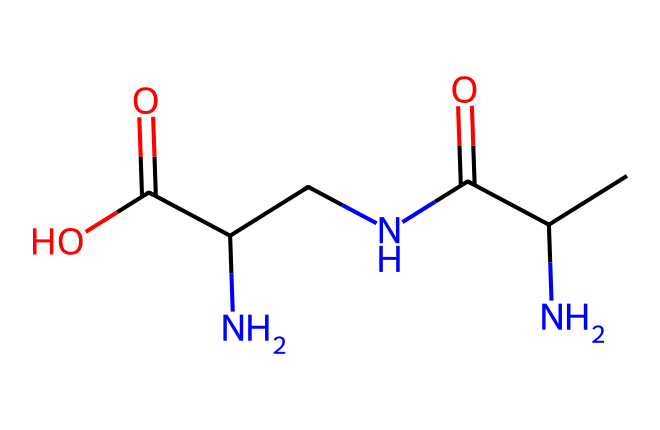How many nitrogen atoms are present in this chemical? By examining the SMILES representation, we can identify nitrogen atoms represented by the letter 'N'. There are three instances of 'N' indicating three nitrogen atoms in total.
Answer: three What type of bonding is indicated in this molecule? The molecule contains both carbon-carbon (C-C) and carbon-nitrogen (C-N) bonds. The structure connects various carbon and nitrogen atoms through single and double bonds as seen in the arrangement.
Answer: covalent What are the functional groups present in theanine? The molecule exhibits several functional groups including amines (due to the nitrogen atoms), carboxylic acids (the presence of C(=O)O), and an amide (C(=O)N) linkage as part of the structure.
Answer: amine, carboxylic acid, amide Is this compound classified as an amino acid? Looking at the presence of the amino group (-NH2) and carboxylic acid group (-COOH) features in its structure, it aligns with the classification criteria for amino acids.
Answer: yes What is the molecular formula based on this structure? By interpreting the composition from the SMILES, we can compute the molecular formula by counting each atom type (C, H, N, O). This leads us to C6H11N3O3, thus providing the molecular formula for theanine.
Answer: C6H11N3O3 Does the structure suggest that theanine has hydrophilic properties? The presence of polar functional groups like the amine and carboxylic acid implies strong interactions with water, which typically indicates hydrophilic behavior in molecules.
Answer: yes 